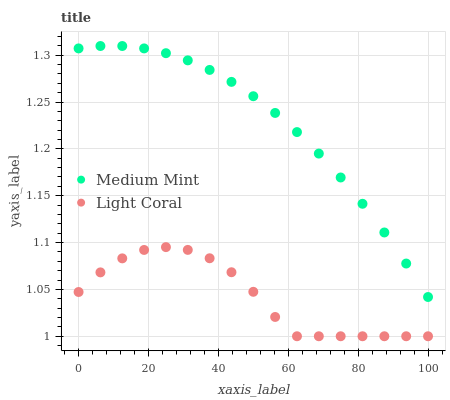Does Light Coral have the minimum area under the curve?
Answer yes or no. Yes. Does Medium Mint have the maximum area under the curve?
Answer yes or no. Yes. Does Light Coral have the maximum area under the curve?
Answer yes or no. No. Is Medium Mint the smoothest?
Answer yes or no. Yes. Is Light Coral the roughest?
Answer yes or no. Yes. Is Light Coral the smoothest?
Answer yes or no. No. Does Light Coral have the lowest value?
Answer yes or no. Yes. Does Medium Mint have the highest value?
Answer yes or no. Yes. Does Light Coral have the highest value?
Answer yes or no. No. Is Light Coral less than Medium Mint?
Answer yes or no. Yes. Is Medium Mint greater than Light Coral?
Answer yes or no. Yes. Does Light Coral intersect Medium Mint?
Answer yes or no. No. 